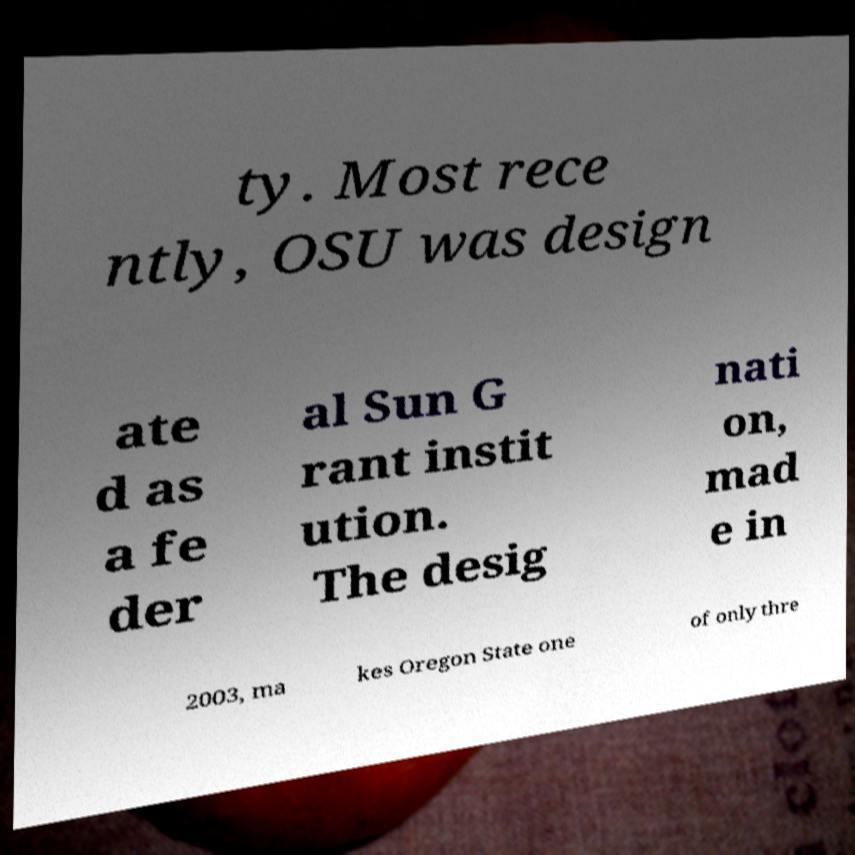Can you read and provide the text displayed in the image?This photo seems to have some interesting text. Can you extract and type it out for me? ty. Most rece ntly, OSU was design ate d as a fe der al Sun G rant instit ution. The desig nati on, mad e in 2003, ma kes Oregon State one of only thre 